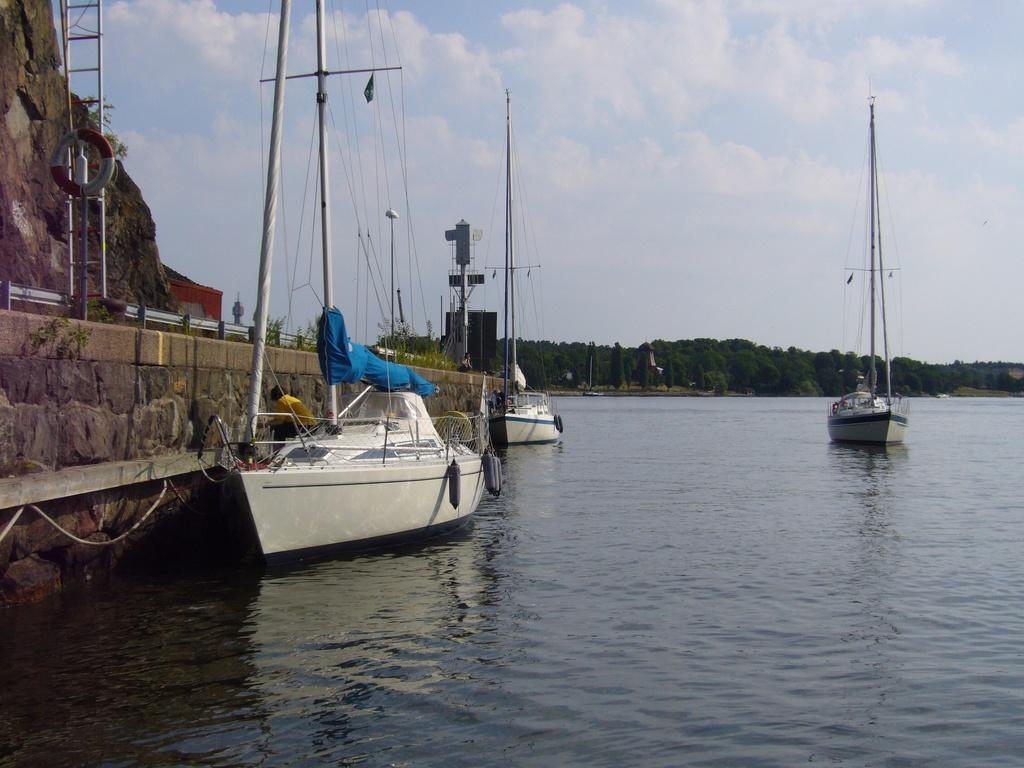Can you describe this image briefly? In the picture we can see water on it, we can see some boats which are white in color with some poles and wires to it and on one boat we can see a person sitting near the path and on the path we can see a railing and some plants on it and a rock hill and in the background we can see full of trees and behind it we can see a sky with clouds. 